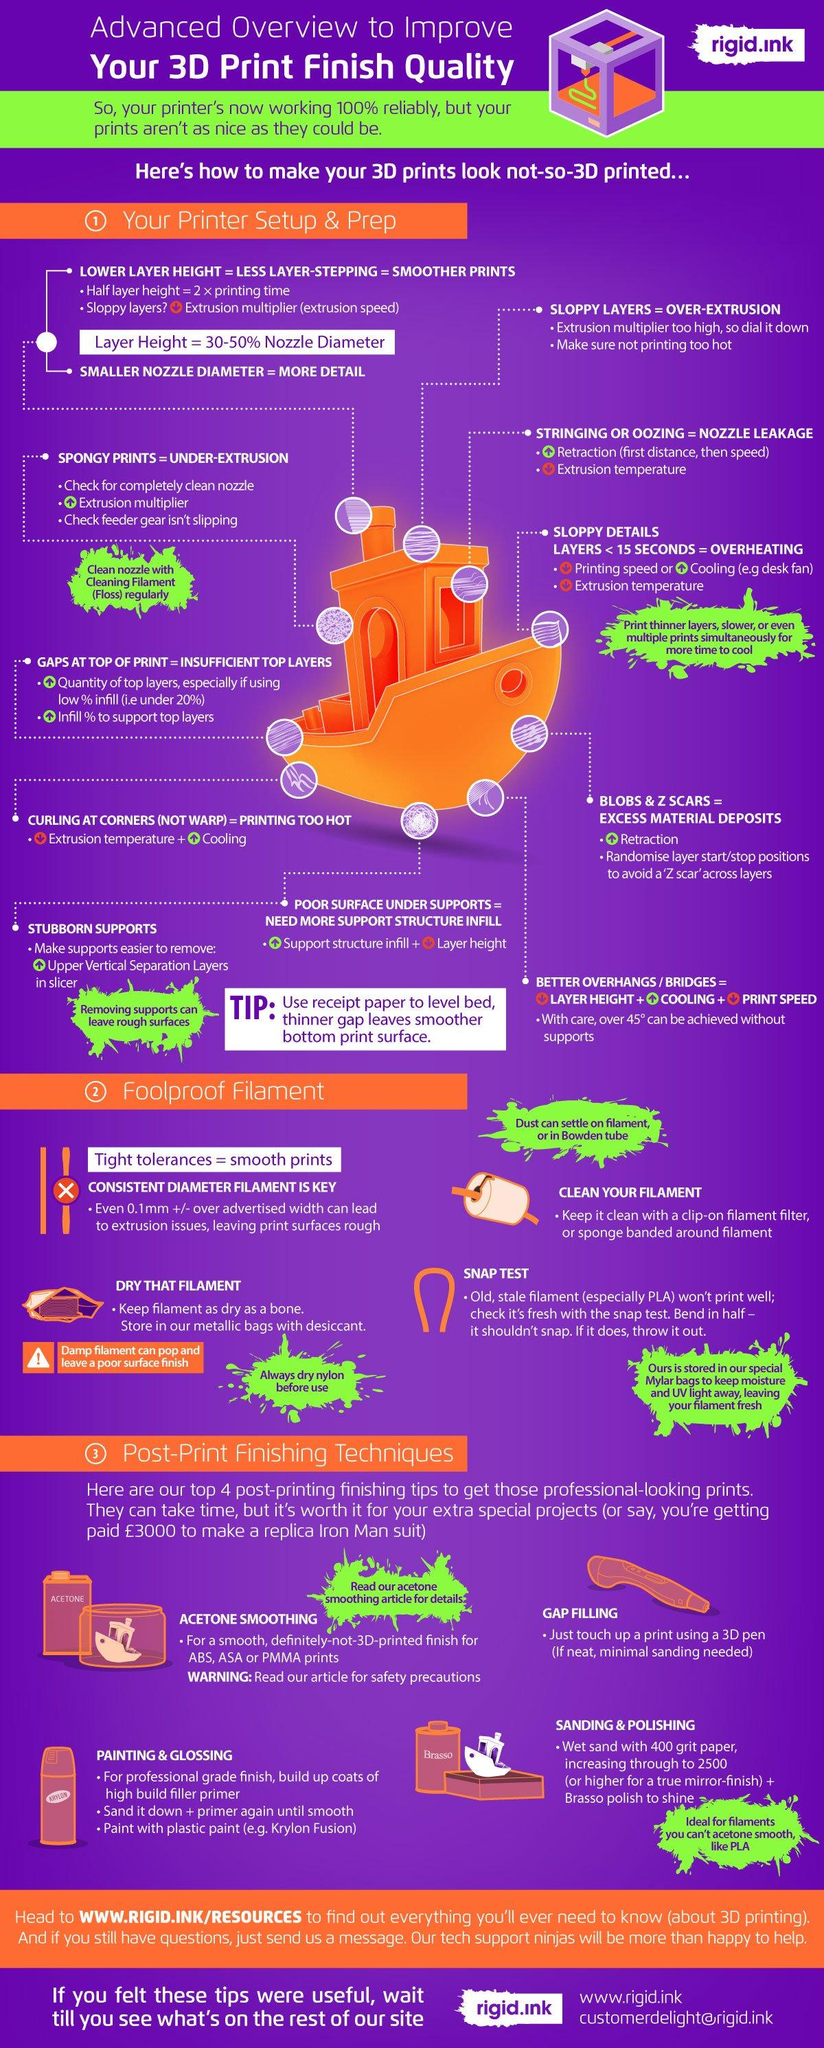Point out several critical features in this image. It is expected that stale filament will snap when bent in half due to its inferior quality. It is recommended to store filament in metallic bags that have been equipped with desiccant in order to maintain the dryness of the filament. I would use a 3D pen to touch up any gaps in a 3D printed object in order to achieve a smooth and seamless finish. 